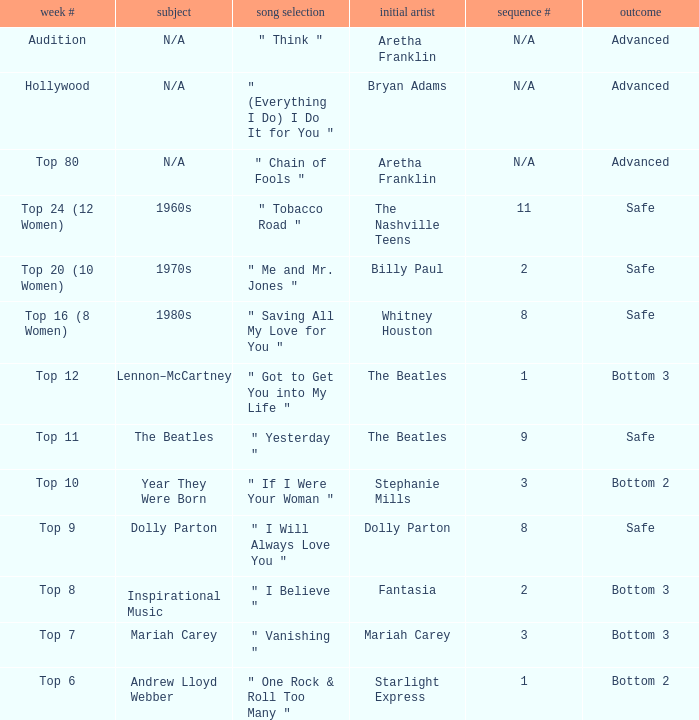Name the week number for andrew lloyd webber Top 6. 